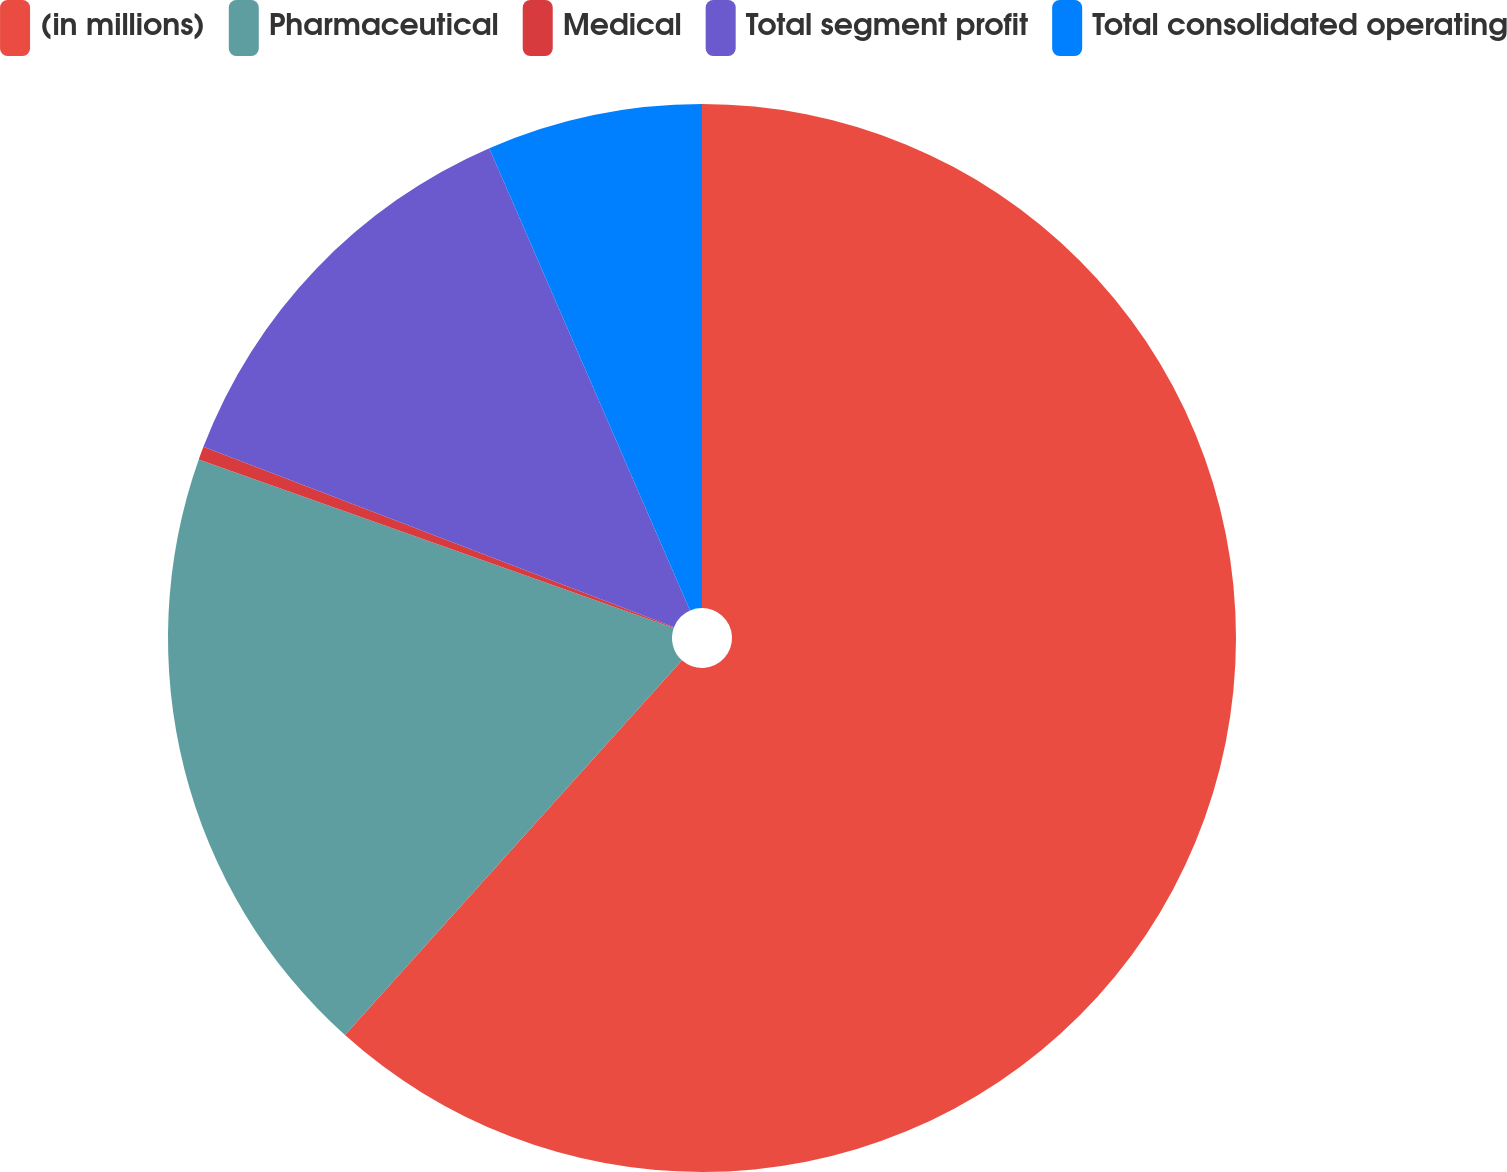Convert chart to OTSL. <chart><loc_0><loc_0><loc_500><loc_500><pie_chart><fcel>(in millions)<fcel>Pharmaceutical<fcel>Medical<fcel>Total segment profit<fcel>Total consolidated operating<nl><fcel>61.65%<fcel>18.77%<fcel>0.4%<fcel>12.65%<fcel>6.52%<nl></chart> 